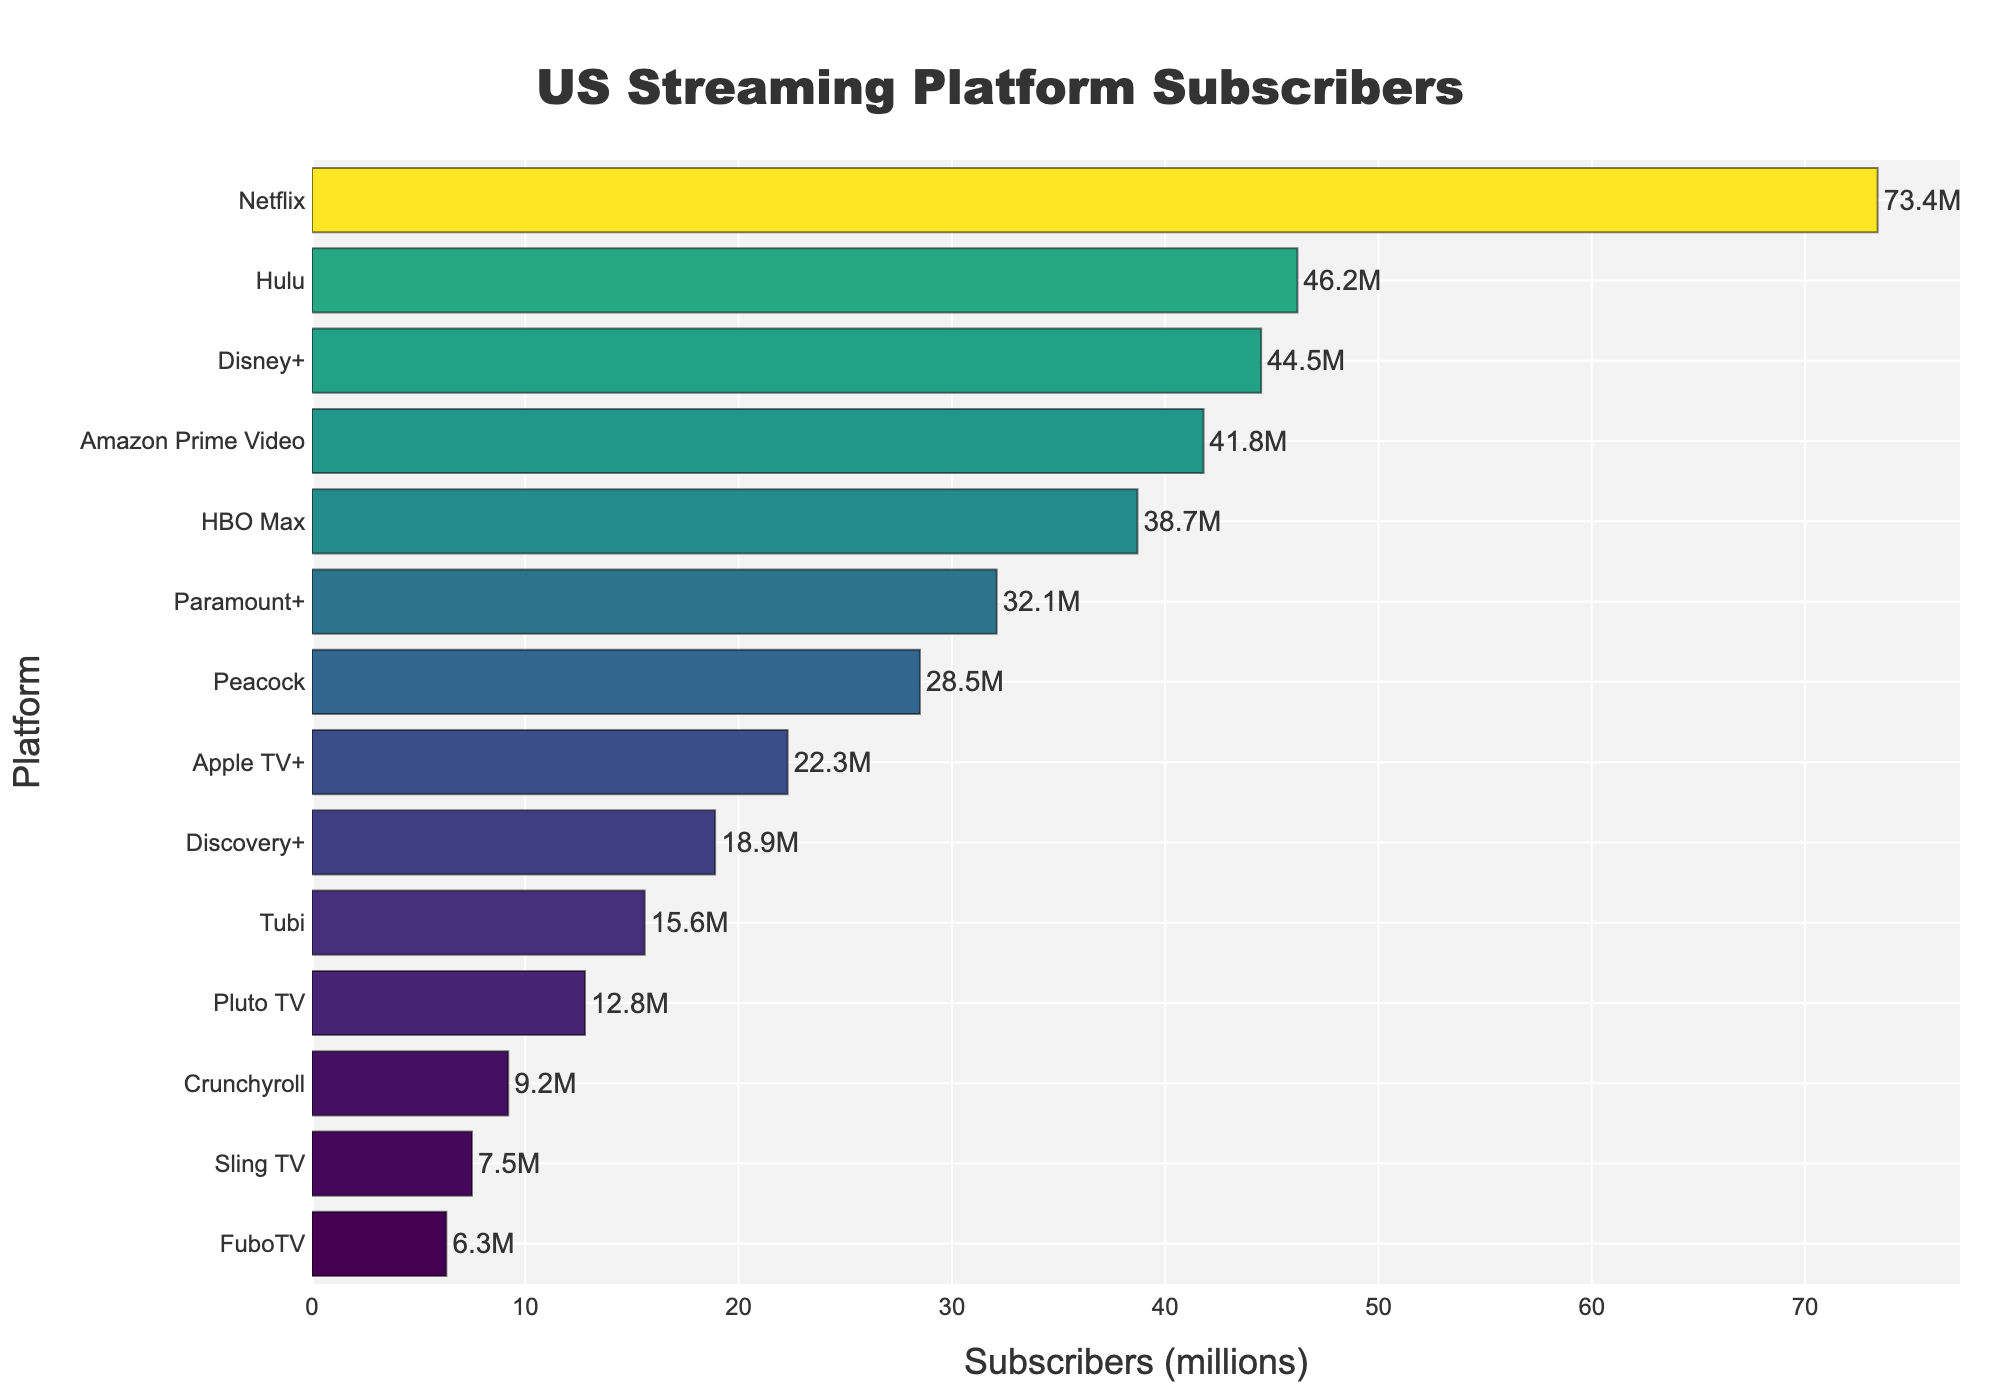Which platform has the highest number of subscribers? The platform with the highest bar and highest value on the x-axis is Netflix.
Answer: Netflix Which platform has fewer subscribers, Hulu or Amazon Prime Video? Hulu has 46.2 million subscribers, and Amazon Prime Video has 41.8 million. Since 41.8 million is less than 46.2 million, Amazon Prime Video has fewer subscribers.
Answer: Amazon Prime Video What's the total number of subscribers for Disney+ and HBO Max? Disney+ has 44.5 million subscribers, and HBO Max has 38.7 million. Adding these gives 44.5 + 38.7 = 83.2 million subscribers.
Answer: 83.2 million Which platform has the second lowest number of subscribers? The second shortest bar corresponds to FuboTV, which has 6.3 million subscribers.
Answer: FuboTV How many subscribers do the platforms with less than 20 million each have in total? Adding the subscribers for Apple TV+ (22.3) is slightly incorrect. Correcting to only include Discovery+ (18.9), Tubi (15.6), Pluto TV (12.8), Crunchyroll (9.2), Sling TV (7.5), and FuboTV (6.3) results in 18.9 + 15.6 + 12.8 + 9.2 + 7.5 + 6.3 = 70.3 million subscribers.
Answer: 70.3 million Which platform has more subscribers, Paramount+ or Peacock? Paramount+ has 32.1 million subscribers, and Peacock has 28.5 million. Since 32.1 is greater than 28.5, Paramount+ has more subscribers.
Answer: Paramount+ What's the difference in subscriber count between Netflix and HBO Max? Netflix has 73.4 million subscribers, and HBO Max has 38.7 million. The difference is 73.4 - 38.7 = 34.7 million subscribers.
Answer: 34.7 million Is there a significant difference between the number of subscribers of Disney+ and Hulu? Hulu has 46.2 million subscribers, while Disney+ has 44.5 million. The difference is 46.2 - 44.5 = 1.7 million subscribers, which is not significant compared to their total subscribers.
Answer: No 